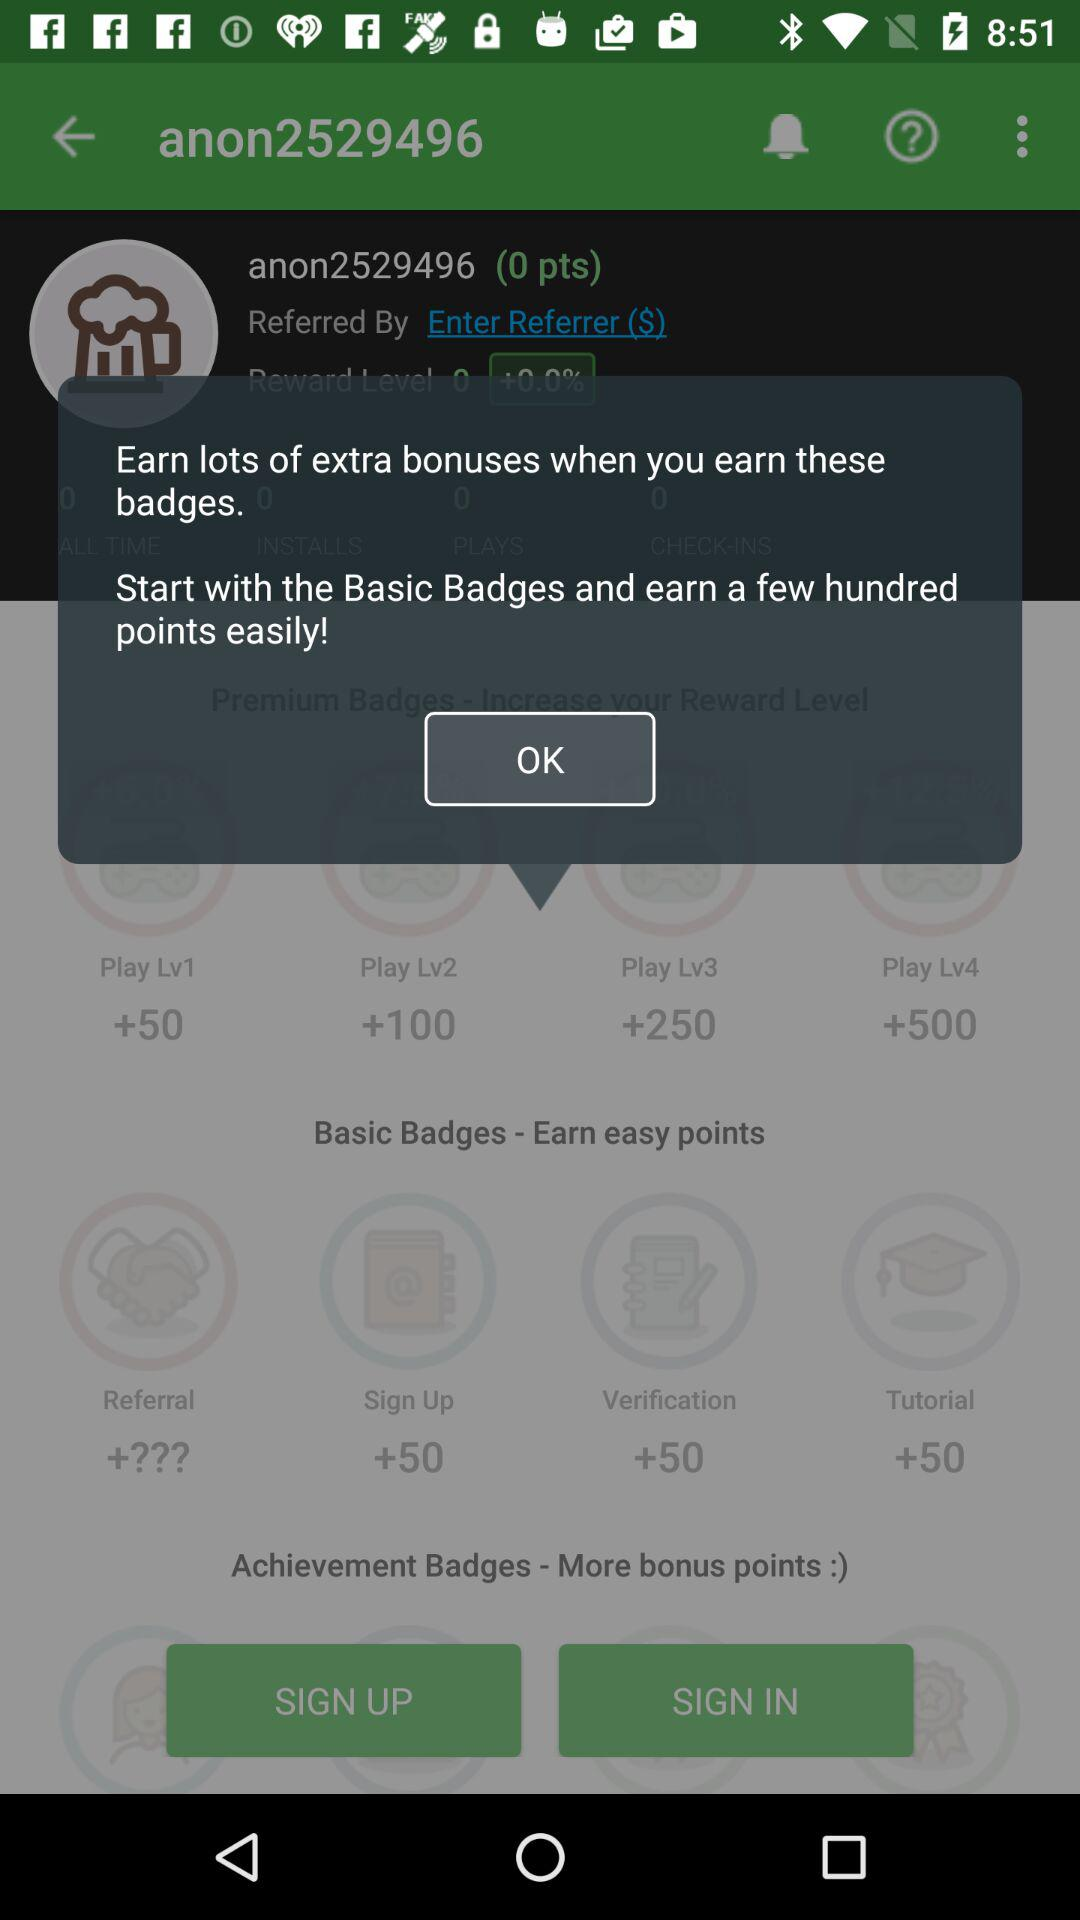What is the highest number of points that can be earned in each level? The highest number of points that can be earned in each level is 50, 100, 250 and 500. 